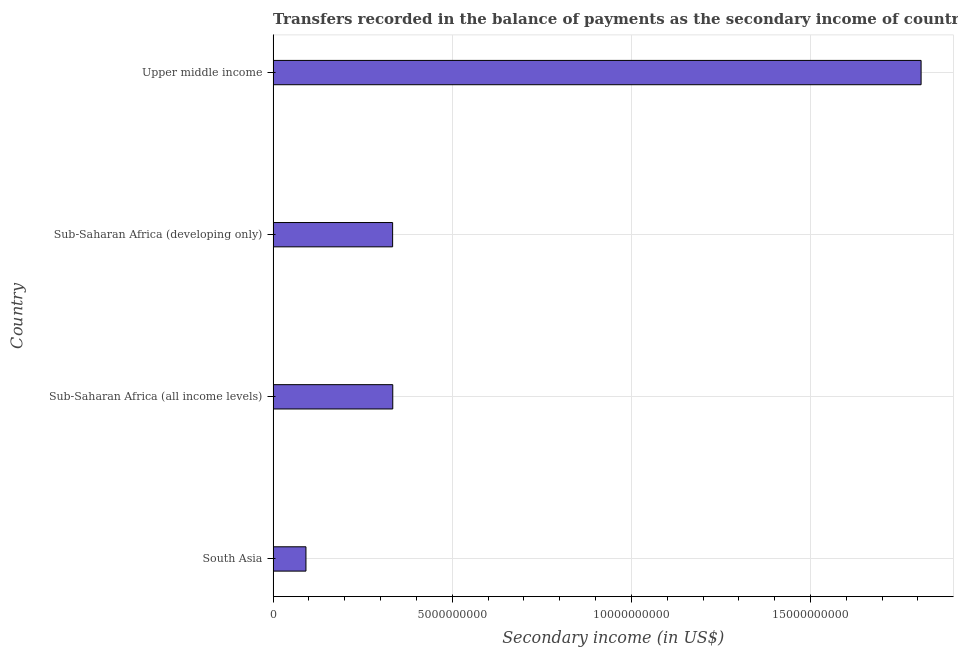Does the graph contain any zero values?
Your response must be concise. No. Does the graph contain grids?
Offer a terse response. Yes. What is the title of the graph?
Make the answer very short. Transfers recorded in the balance of payments as the secondary income of countries in the year 2005. What is the label or title of the X-axis?
Provide a succinct answer. Secondary income (in US$). What is the amount of secondary income in Sub-Saharan Africa (developing only)?
Keep it short and to the point. 3.34e+09. Across all countries, what is the maximum amount of secondary income?
Your answer should be very brief. 1.81e+1. Across all countries, what is the minimum amount of secondary income?
Your answer should be compact. 9.16e+08. In which country was the amount of secondary income maximum?
Give a very brief answer. Upper middle income. In which country was the amount of secondary income minimum?
Your answer should be very brief. South Asia. What is the sum of the amount of secondary income?
Keep it short and to the point. 2.57e+1. What is the difference between the amount of secondary income in South Asia and Upper middle income?
Give a very brief answer. -1.72e+1. What is the average amount of secondary income per country?
Give a very brief answer. 6.42e+09. What is the median amount of secondary income?
Offer a very short reply. 3.34e+09. In how many countries, is the amount of secondary income greater than 2000000000 US$?
Give a very brief answer. 3. What is the ratio of the amount of secondary income in South Asia to that in Upper middle income?
Offer a terse response. 0.05. Is the difference between the amount of secondary income in South Asia and Sub-Saharan Africa (all income levels) greater than the difference between any two countries?
Provide a succinct answer. No. What is the difference between the highest and the second highest amount of secondary income?
Ensure brevity in your answer.  1.47e+1. Is the sum of the amount of secondary income in South Asia and Sub-Saharan Africa (all income levels) greater than the maximum amount of secondary income across all countries?
Your answer should be compact. No. What is the difference between the highest and the lowest amount of secondary income?
Your response must be concise. 1.72e+1. Are all the bars in the graph horizontal?
Provide a short and direct response. Yes. How many countries are there in the graph?
Provide a short and direct response. 4. What is the difference between two consecutive major ticks on the X-axis?
Offer a terse response. 5.00e+09. What is the Secondary income (in US$) in South Asia?
Your response must be concise. 9.16e+08. What is the Secondary income (in US$) in Sub-Saharan Africa (all income levels)?
Your answer should be very brief. 3.34e+09. What is the Secondary income (in US$) of Sub-Saharan Africa (developing only)?
Ensure brevity in your answer.  3.34e+09. What is the Secondary income (in US$) of Upper middle income?
Make the answer very short. 1.81e+1. What is the difference between the Secondary income (in US$) in South Asia and Sub-Saharan Africa (all income levels)?
Your answer should be very brief. -2.42e+09. What is the difference between the Secondary income (in US$) in South Asia and Sub-Saharan Africa (developing only)?
Your answer should be very brief. -2.42e+09. What is the difference between the Secondary income (in US$) in South Asia and Upper middle income?
Your response must be concise. -1.72e+1. What is the difference between the Secondary income (in US$) in Sub-Saharan Africa (all income levels) and Sub-Saharan Africa (developing only)?
Offer a very short reply. 3.99e+06. What is the difference between the Secondary income (in US$) in Sub-Saharan Africa (all income levels) and Upper middle income?
Offer a terse response. -1.47e+1. What is the difference between the Secondary income (in US$) in Sub-Saharan Africa (developing only) and Upper middle income?
Your answer should be very brief. -1.48e+1. What is the ratio of the Secondary income (in US$) in South Asia to that in Sub-Saharan Africa (all income levels)?
Offer a very short reply. 0.27. What is the ratio of the Secondary income (in US$) in South Asia to that in Sub-Saharan Africa (developing only)?
Your answer should be compact. 0.28. What is the ratio of the Secondary income (in US$) in South Asia to that in Upper middle income?
Make the answer very short. 0.05. What is the ratio of the Secondary income (in US$) in Sub-Saharan Africa (all income levels) to that in Upper middle income?
Your answer should be compact. 0.18. What is the ratio of the Secondary income (in US$) in Sub-Saharan Africa (developing only) to that in Upper middle income?
Keep it short and to the point. 0.18. 